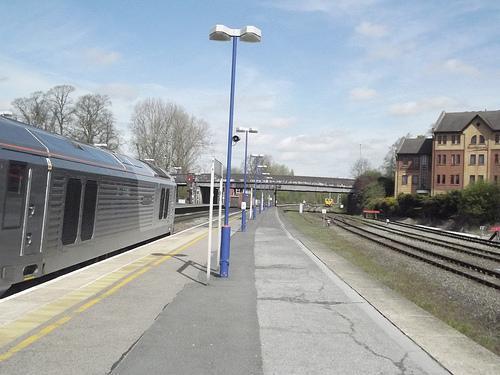How many windows are on the train in the picture?
Give a very brief answer. 4. 